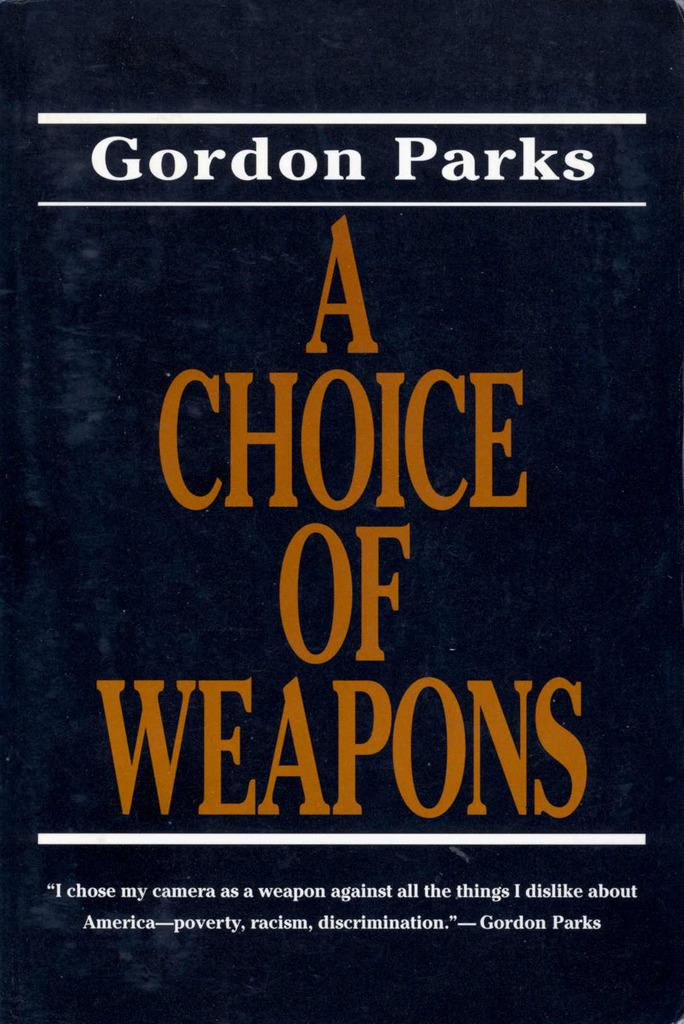<image>
Describe the image concisely. A blue book with the title a choice of weapons.. 